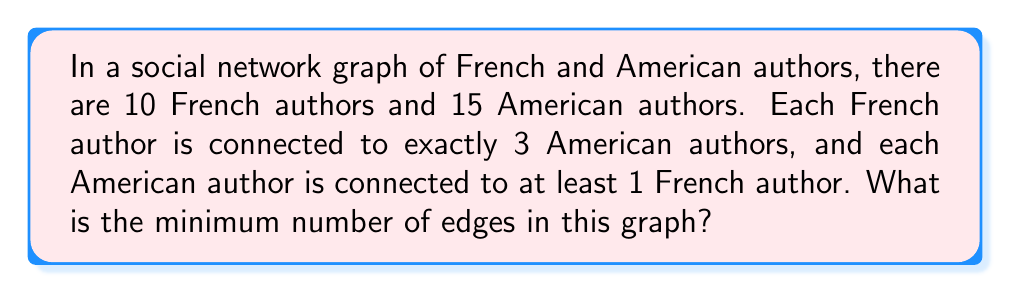Give your solution to this math problem. Let's approach this step-by-step:

1) First, we need to understand what the question is asking. We're looking for the minimum number of edges in a bipartite graph where:
   - One set (French authors) has 10 nodes
   - The other set (American authors) has 15 nodes
   - Each node in the French set is connected to exactly 3 nodes in the American set
   - Each node in the American set is connected to at least 1 node in the French set

2) Let's start with the French authors. We know that:
   - There are 10 French authors
   - Each French author is connected to exactly 3 American authors

   So, the total number of edges from the French perspective is:
   $$ 10 \times 3 = 30 $$

3) Now, we need to check if this satisfies the condition for American authors. We know that:
   - There are 15 American authors
   - Each American author must be connected to at least 1 French author

4) To minimize the number of edges, we want to distribute these 30 connections as evenly as possible among the 15 American authors. We can do this by:
   $$ \left\lfloor \frac{30}{15} \right\rfloor = 2 $$
   This means we can connect 2 French authors to each American author, and still have some connections left.

5) After connecting 2 French authors to each American author, we've used:
   $$ 15 \times 2 = 30 $$
   connections, which is exactly the number we have.

6) This distribution ensures that each American author is connected to at least 1 French author (in fact, at least 2), and uses all 30 connections from the French authors.

Therefore, the minimum number of edges in this graph is 30.
Answer: 30 edges 